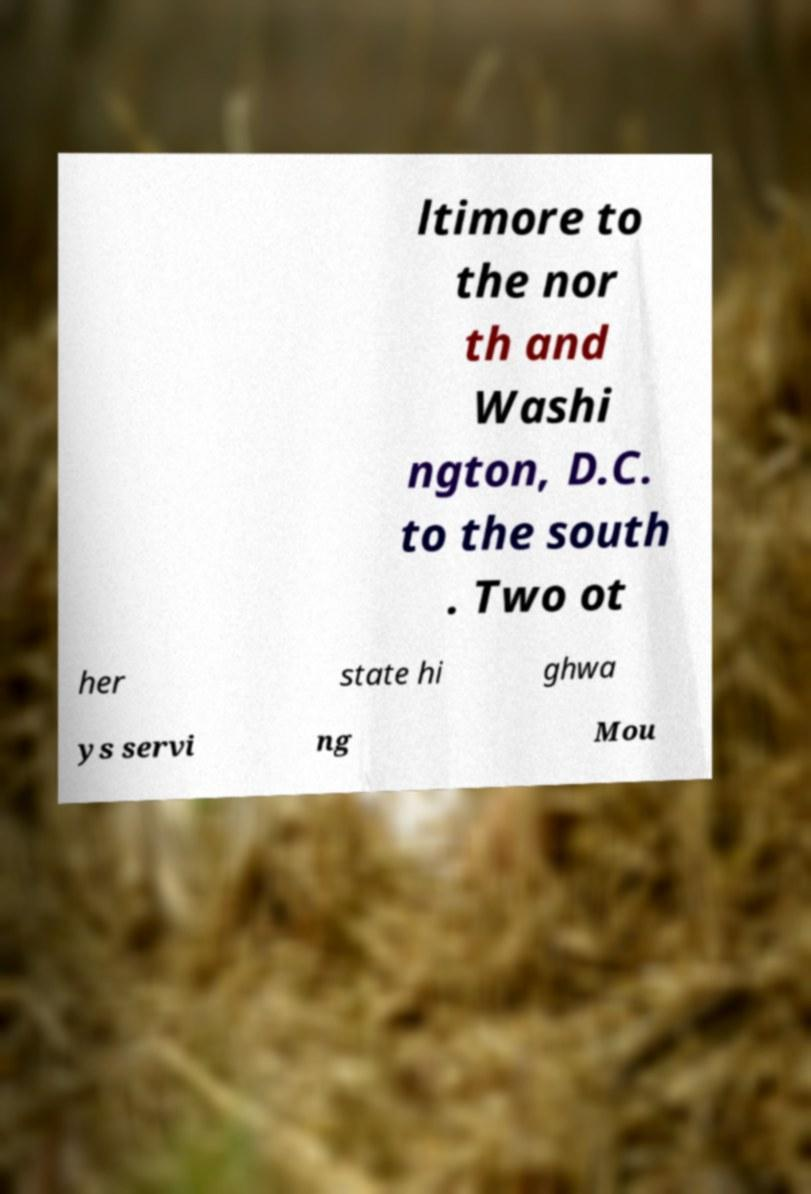Could you assist in decoding the text presented in this image and type it out clearly? ltimore to the nor th and Washi ngton, D.C. to the south . Two ot her state hi ghwa ys servi ng Mou 